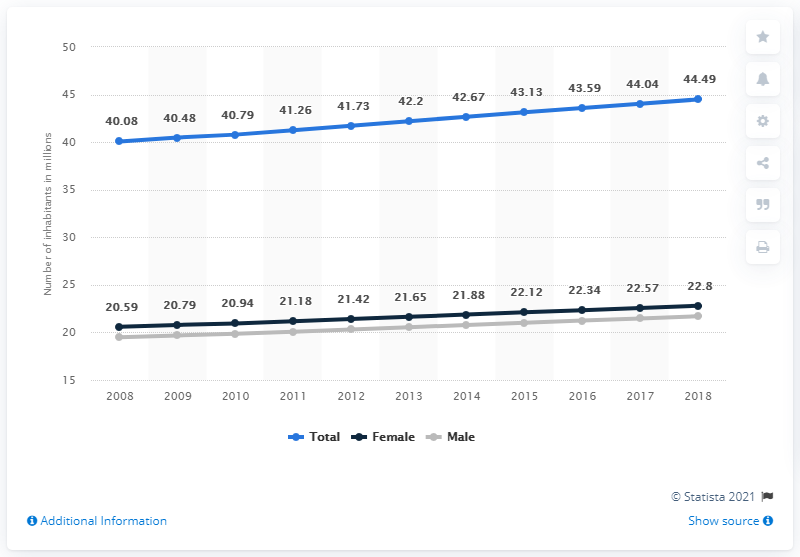Mention a couple of crucial points in this snapshot. In 2018, it is estimated that approximately 21.7 million men lived in Argentina. In 2018, the estimated number of women in Argentina was 22.8 million. In 2018, the estimated number of women in Argentina was 22.8. 